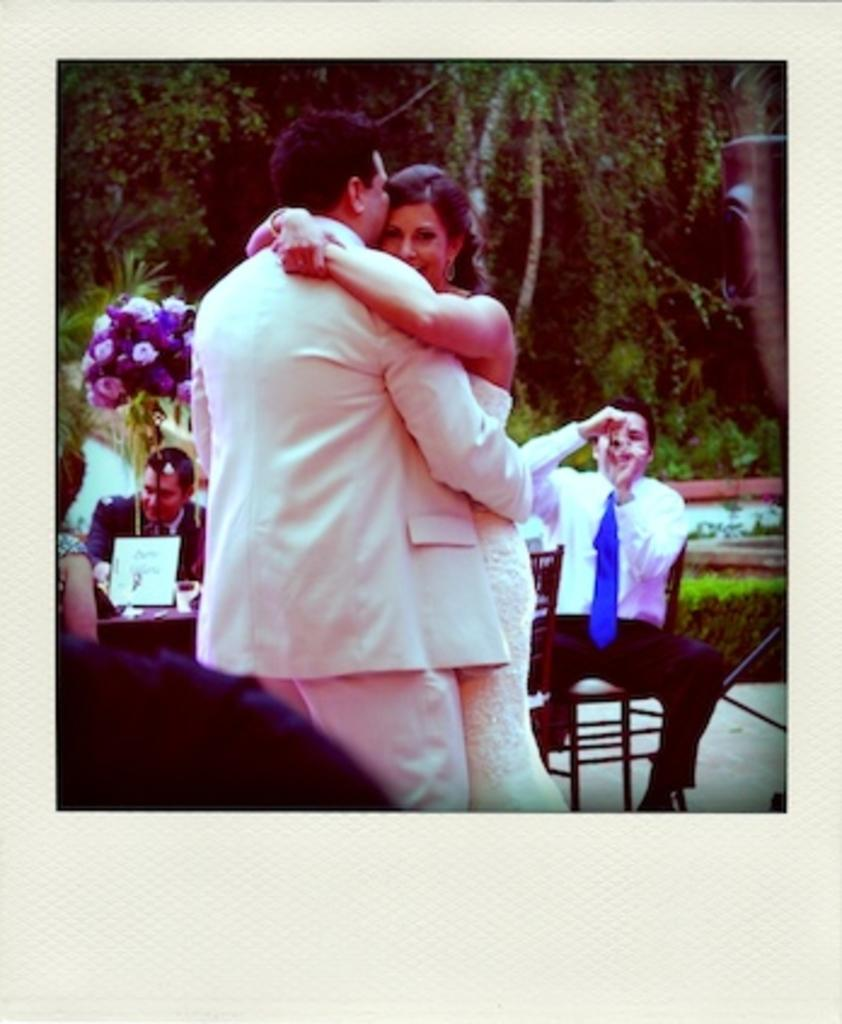How many people are standing in the image? There are two people standing in the image. What are the people in the image doing? There are people standing and sitting in the image. What type of vegetation can be seen in the image? There are flowers, plants, and trees visible in the image. What else can be seen in the image besides people and vegetation? There are objects in the image. What discovery did the person make in the image? There is no indication of a discovery being made in the image. What is the best way to reach the top of the tree in the image? There is no tree present in the image, so it is not possible to determine the best way to reach the top. 